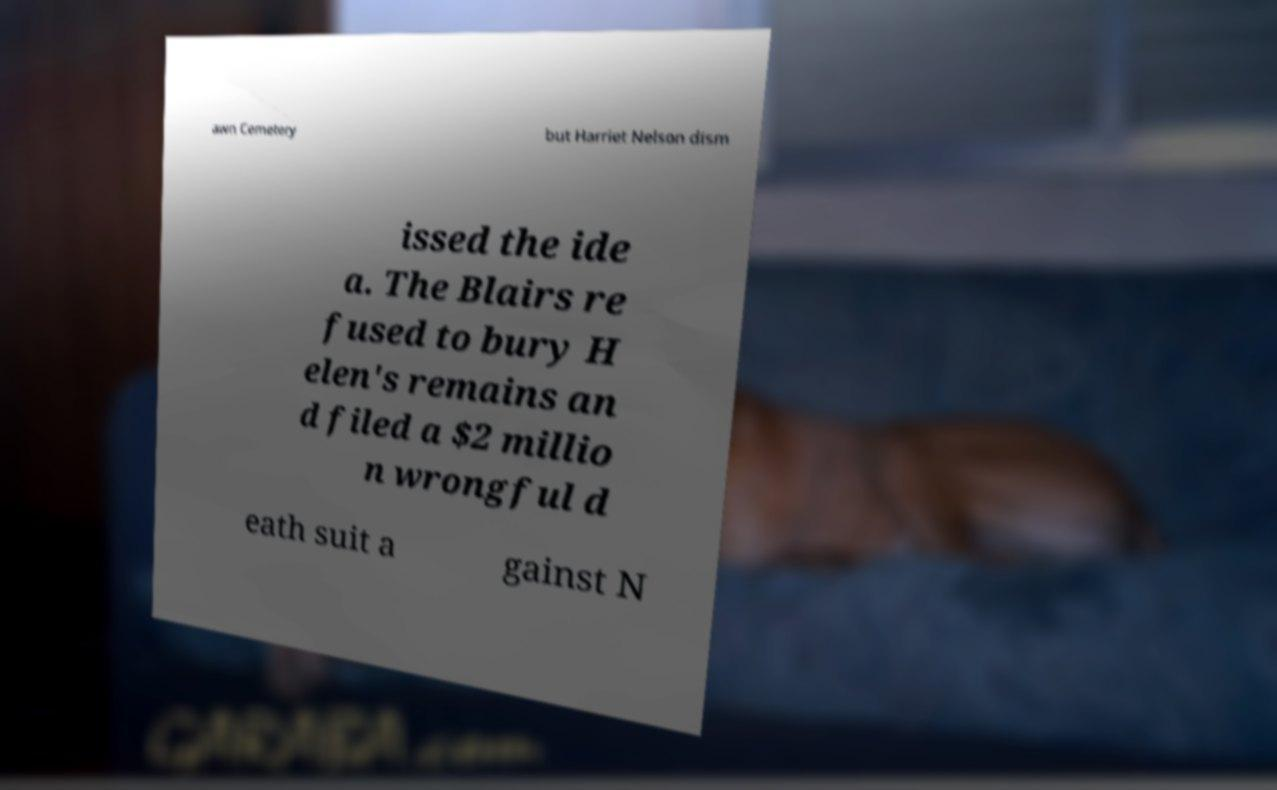There's text embedded in this image that I need extracted. Can you transcribe it verbatim? awn Cemetery but Harriet Nelson dism issed the ide a. The Blairs re fused to bury H elen's remains an d filed a $2 millio n wrongful d eath suit a gainst N 